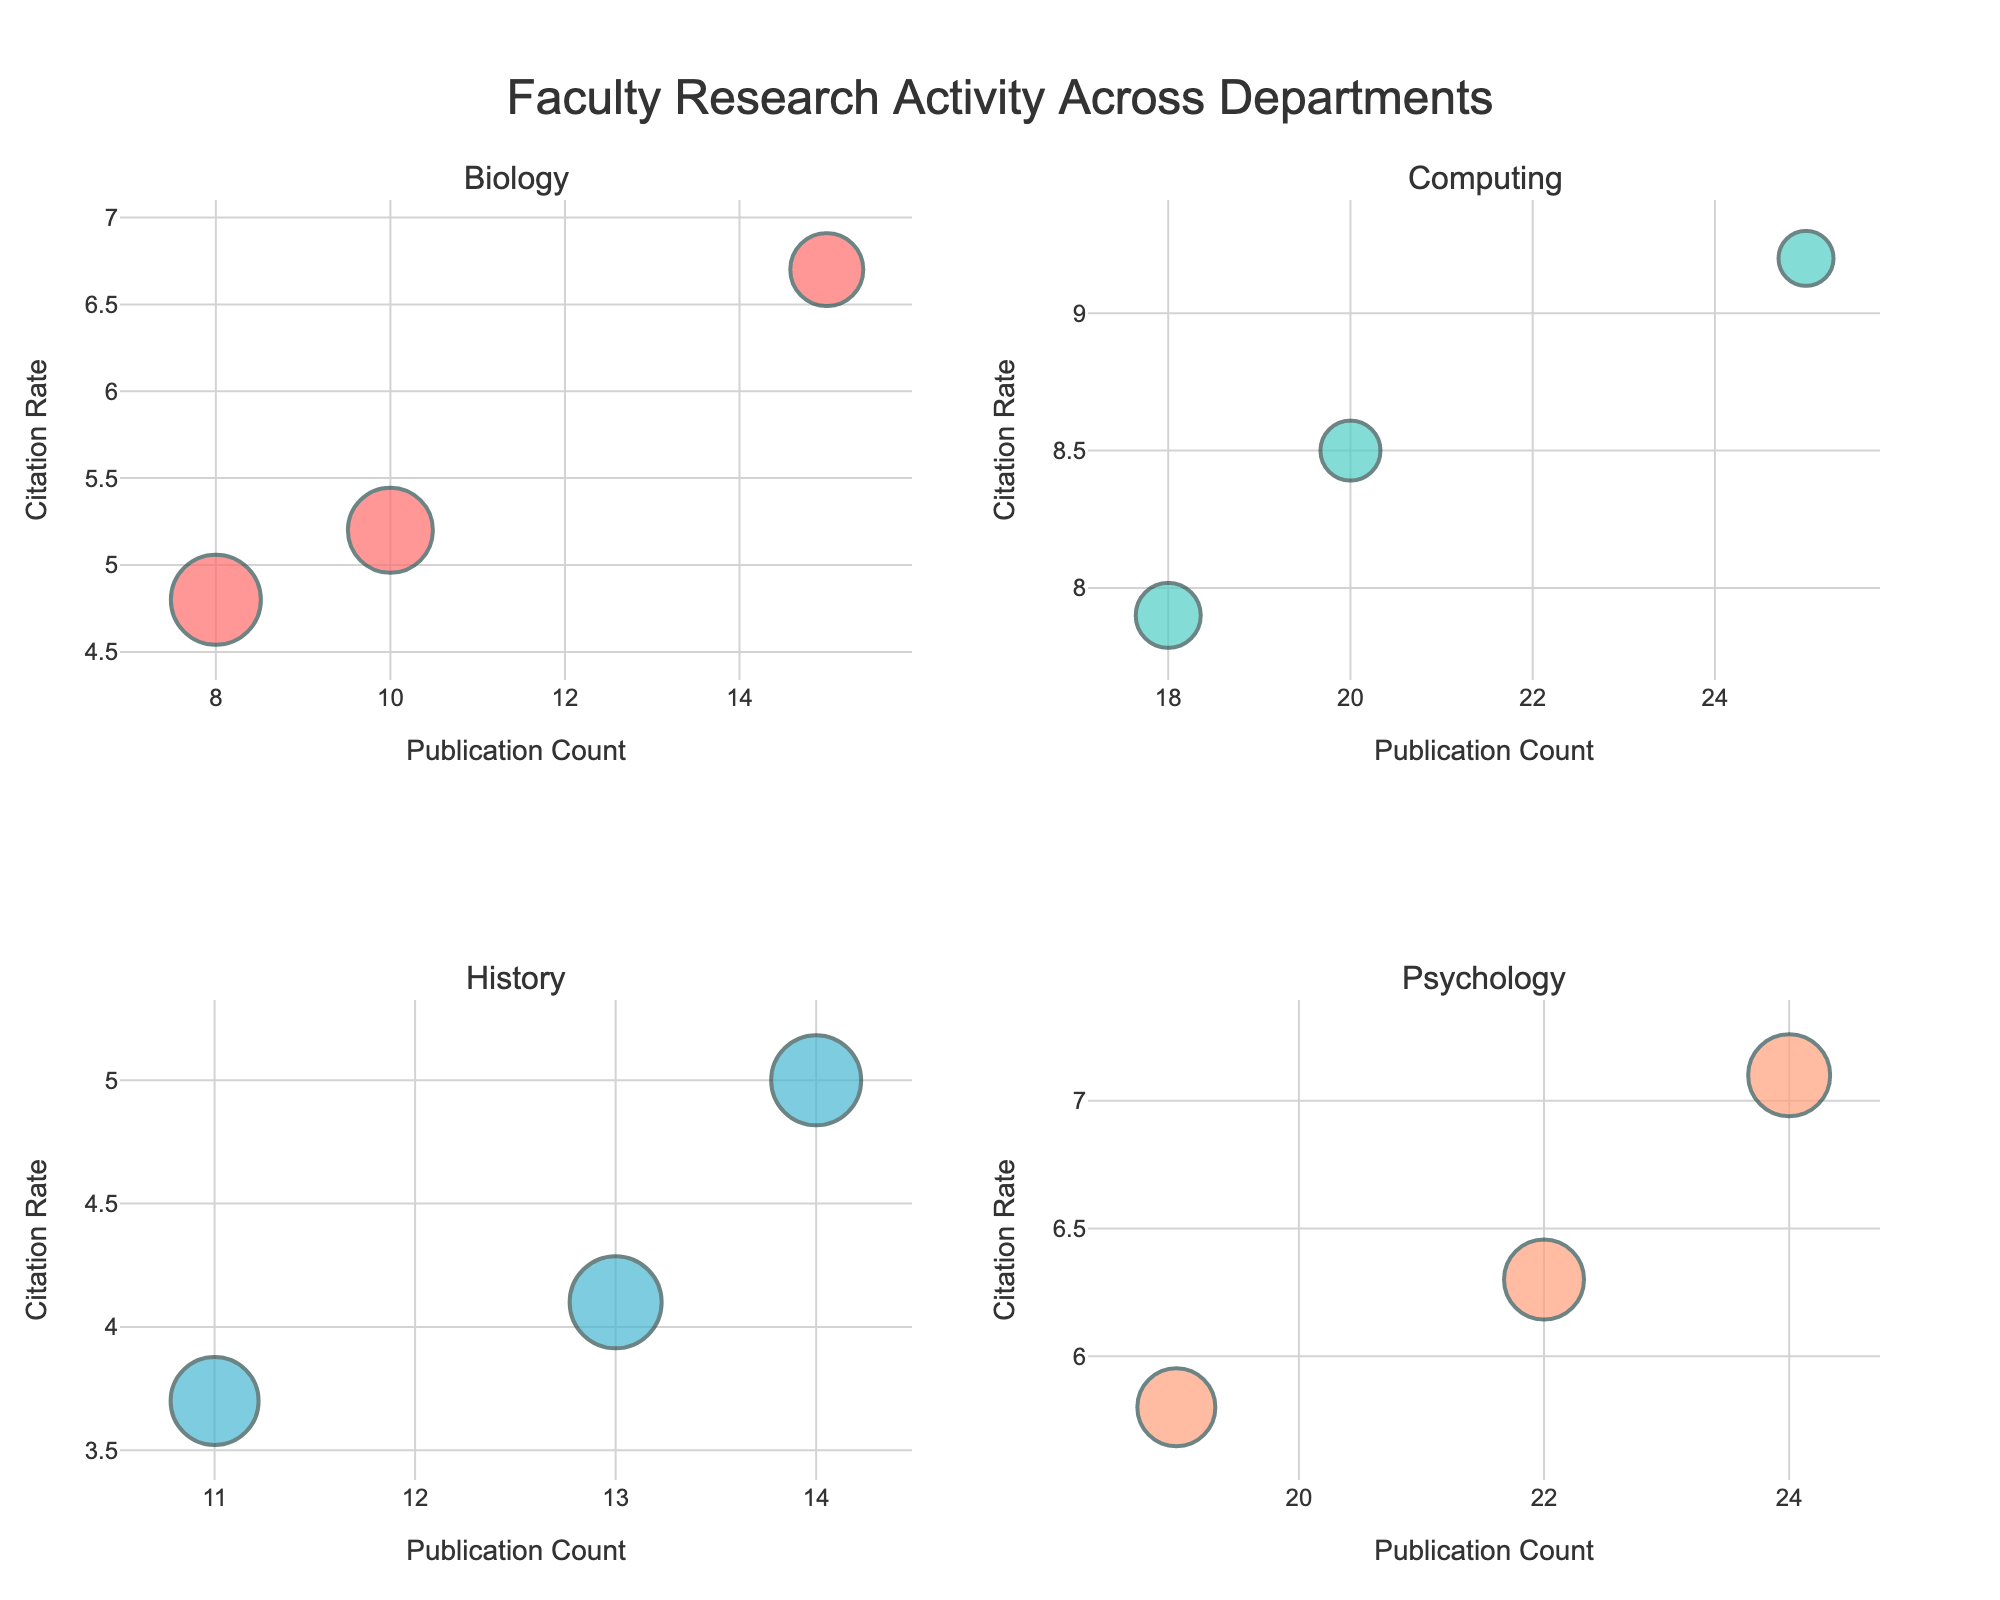What is the title of the overall subplot figure? The title of the figure is at the top center, indicating its main theme.
Answer: Faculty Research Activity Across Departments How many departments are shown in the subplots? Each subplot represents a different department, and there are four subplot titles, one for each department.
Answer: 4 Which department has the highest publication count? By observing the x-axes of all subplots, the highest publication count is in the Computing department with a data point of 25 publications.
Answer: Computing How does the citation rate compare between Biology and History departments for the highest publication counts? Compare the data points with the highest publication counts in each subplot. Biology's highest is around 15 with a citation rate of 6.7, whereas History's highest is 14 with a citation rate of 5.0.
Answer: Biology has a higher citation rate Which department shows the largest bubble, and what does this represent? The largest bubbles represent the highest Collaboration Index. The Psychology department has the largest bubble.
Answer: Psychology Among the Psychology department data points, what is the Collaboration Index of the publication with the highest Citation Rate? Identify the highest y-value in the Psychology subplot and check the hover text or size. The publication with the highest citation rate of 7.1 has a Collaboration Index represented by the largest bubble size.
Answer: 0.82 What is the difference in citation rate between the highest and lowest publication counts in the Computing department? In the Computing subplot, the highest publication count is 25 with a citation rate of 9.2, and the lowest is 18 with a citation rate of 7.9. The difference is 9.2 - 7.9.
Answer: 1.3 Which department exhibits the highest variability in Collaboration Index, based on the bubble sizes? By observing and comparing bubble sizes across departments, History displays a wide range of bubble sizes indicating high variability in Collaboration Index values.
Answer: History What can be inferred about the relationship between publication count and collaboration index in the Marketing department? In the Marketing subplot, observe how bubble sizes change with publication counts. There seems to be a consistent collaboration index regardless of publication count.
Answer: Consistent collaboration index Between Environmental Science and Biology, which department has a higher average citation rate? Calculate the average citation rate by summing the citation rates and dividing by the number of points. Biology: (5.2+6.7+4.8)/3; Environmental Science: (6.0+6.5+5.4)/3. Compare these averages.
Answer: Environmental Science 